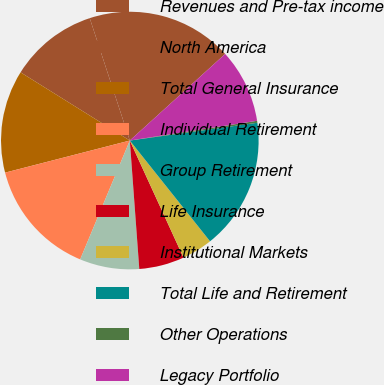Convert chart. <chart><loc_0><loc_0><loc_500><loc_500><pie_chart><fcel>Revenues and Pre-tax income<fcel>North America<fcel>Total General Insurance<fcel>Individual Retirement<fcel>Group Retirement<fcel>Life Insurance<fcel>Institutional Markets<fcel>Total Life and Retirement<fcel>Other Operations<fcel>Legacy Portfolio<nl><fcel>18.3%<fcel>11.08%<fcel>12.89%<fcel>14.69%<fcel>7.47%<fcel>5.67%<fcel>3.86%<fcel>16.5%<fcel>0.25%<fcel>9.28%<nl></chart> 